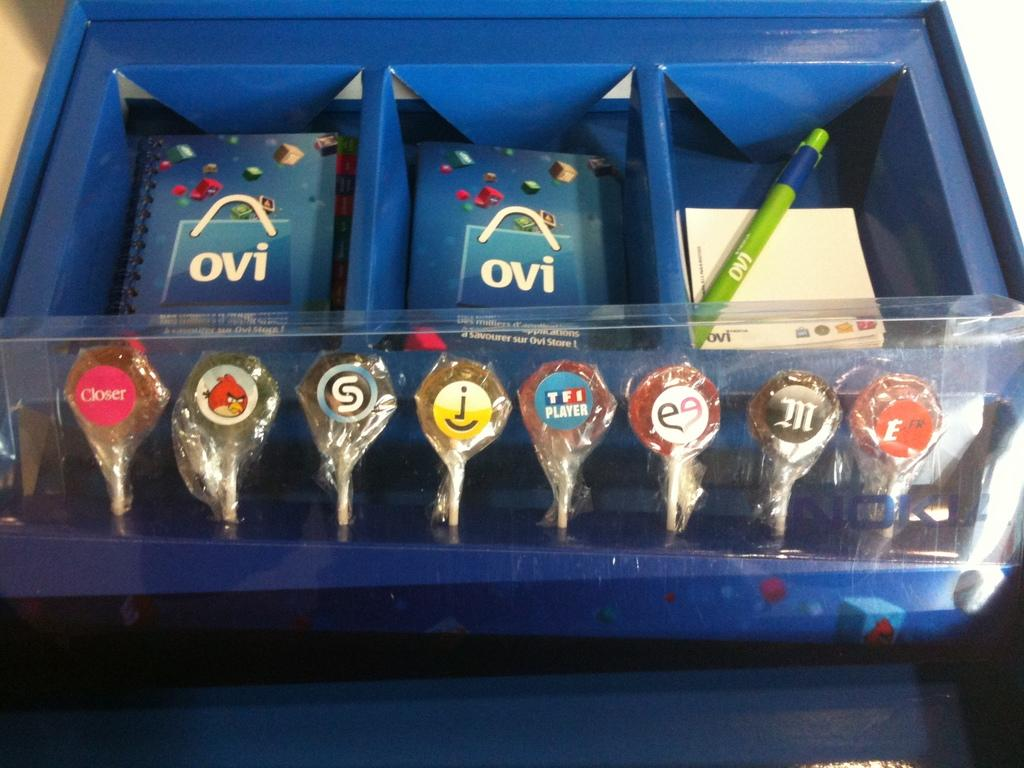<image>
Render a clear and concise summary of the photo. A blue container with OVI brochures sitting behind lollipops. 